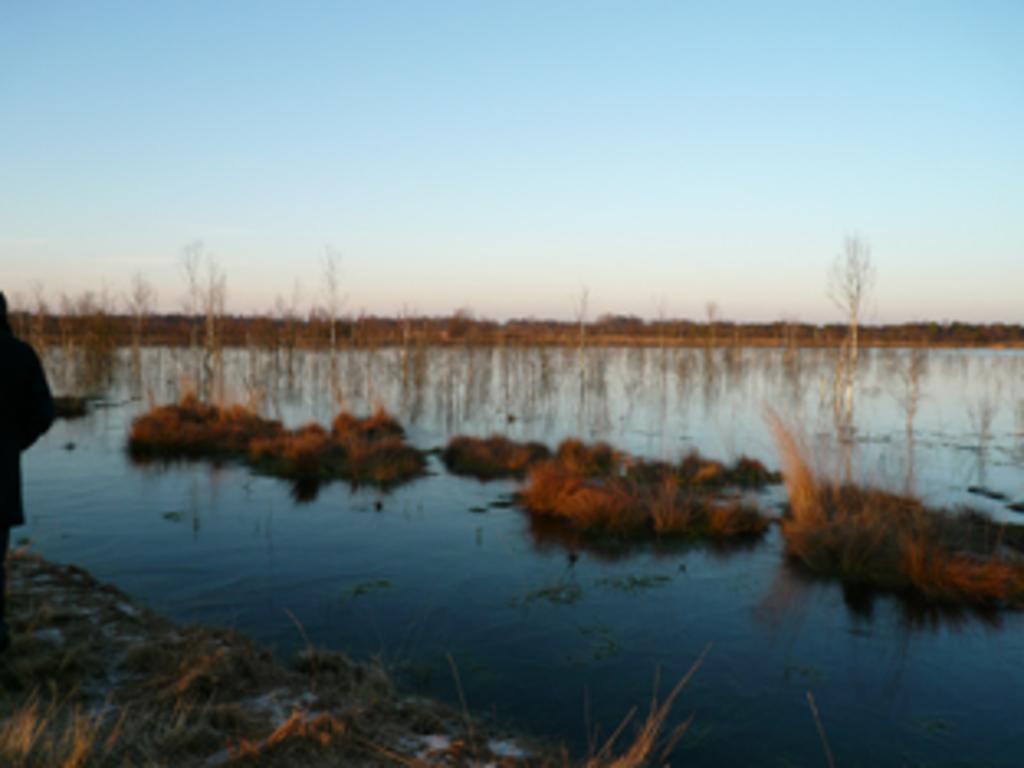Please provide a concise description of this image. In this image there is a lake on which we can see there is some grass and plants. 